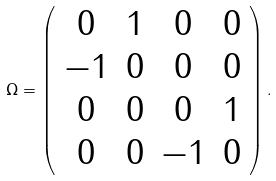Convert formula to latex. <formula><loc_0><loc_0><loc_500><loc_500>\Omega = \left ( \begin{array} { c c c c } 0 & 1 & 0 & 0 \\ - 1 & 0 & 0 & 0 \\ 0 & 0 & 0 & 1 \\ 0 & 0 & - 1 & 0 \end{array} \right ) .</formula> 